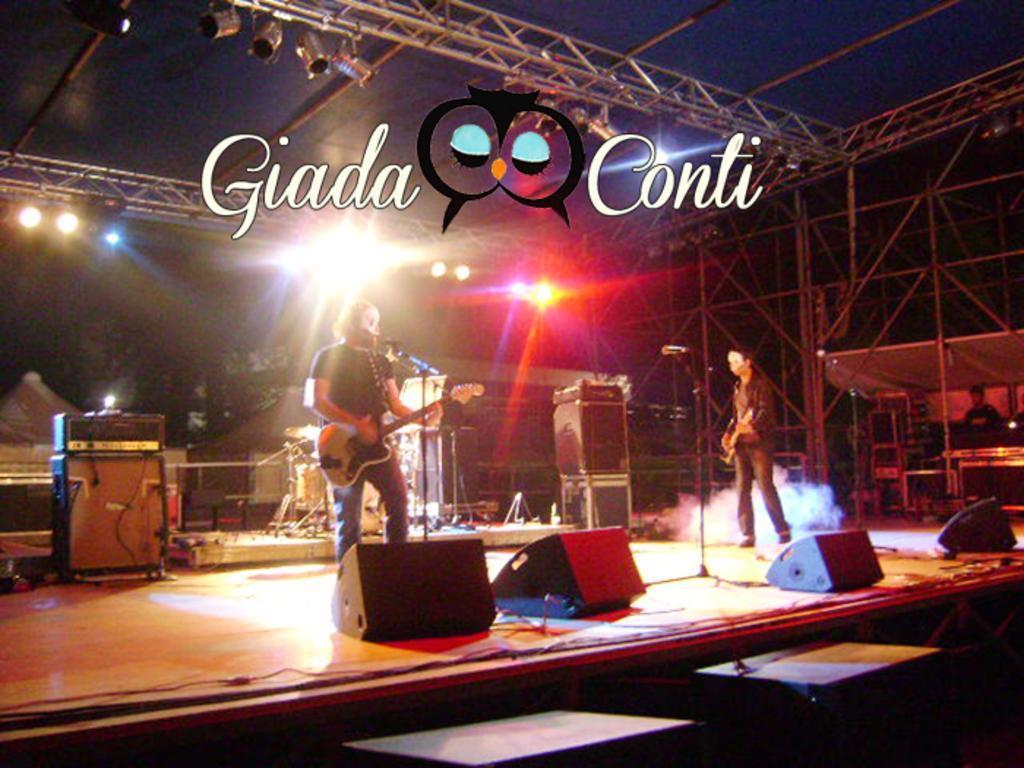Describe this image in one or two sentences. In this Image I see 2 men who are holding their guitars and this man is standing in front of a mic. In the background I see the lights, few equipment and the smoke and I can also see another person over here. 